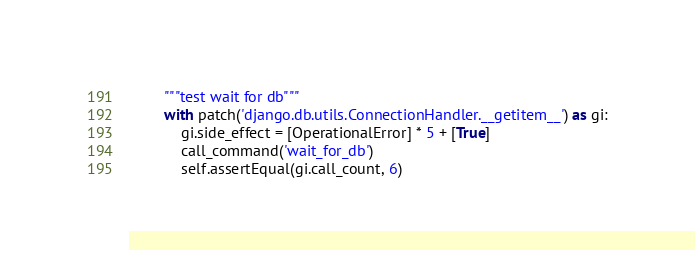<code> <loc_0><loc_0><loc_500><loc_500><_Python_>		"""test wait for db"""
		with patch('django.db.utils.ConnectionHandler.__getitem__') as gi:
			gi.side_effect = [OperationalError] * 5 + [True]
			call_command('wait_for_db')
			self.assertEqual(gi.call_count, 6)

</code> 